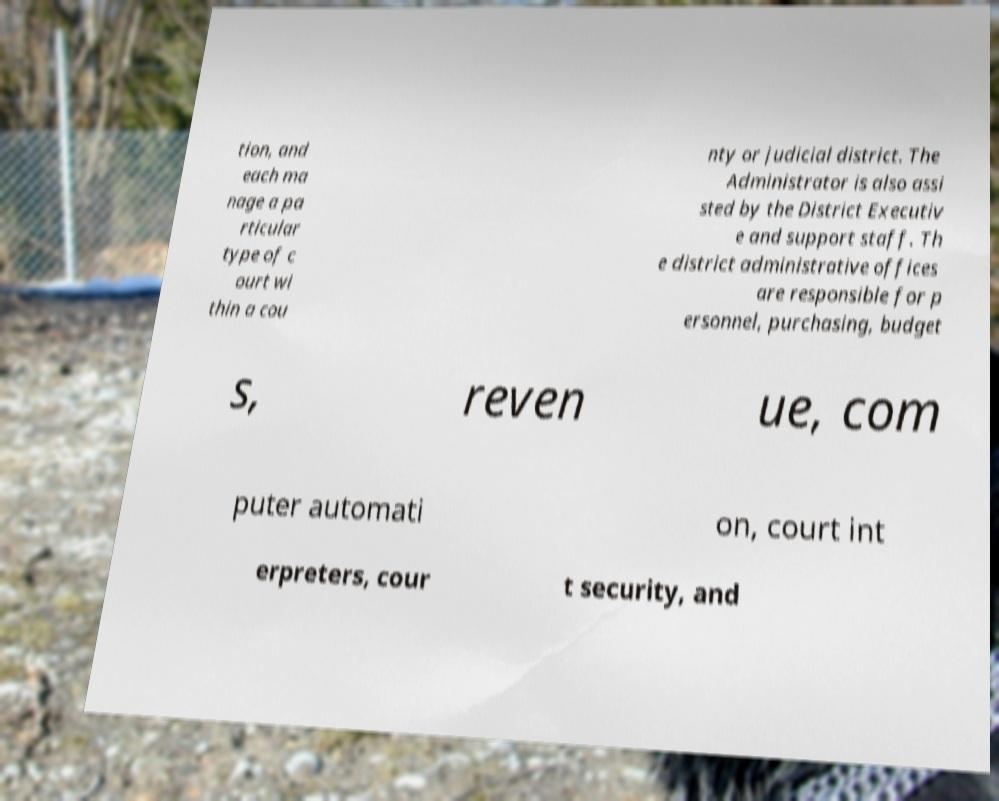Could you assist in decoding the text presented in this image and type it out clearly? tion, and each ma nage a pa rticular type of c ourt wi thin a cou nty or judicial district. The Administrator is also assi sted by the District Executiv e and support staff. Th e district administrative offices are responsible for p ersonnel, purchasing, budget s, reven ue, com puter automati on, court int erpreters, cour t security, and 